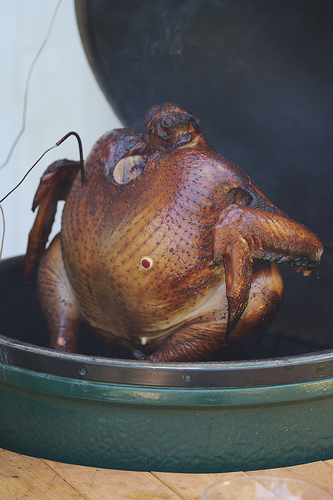<image>
Is the chicken next to the table? No. The chicken is not positioned next to the table. They are located in different areas of the scene. 